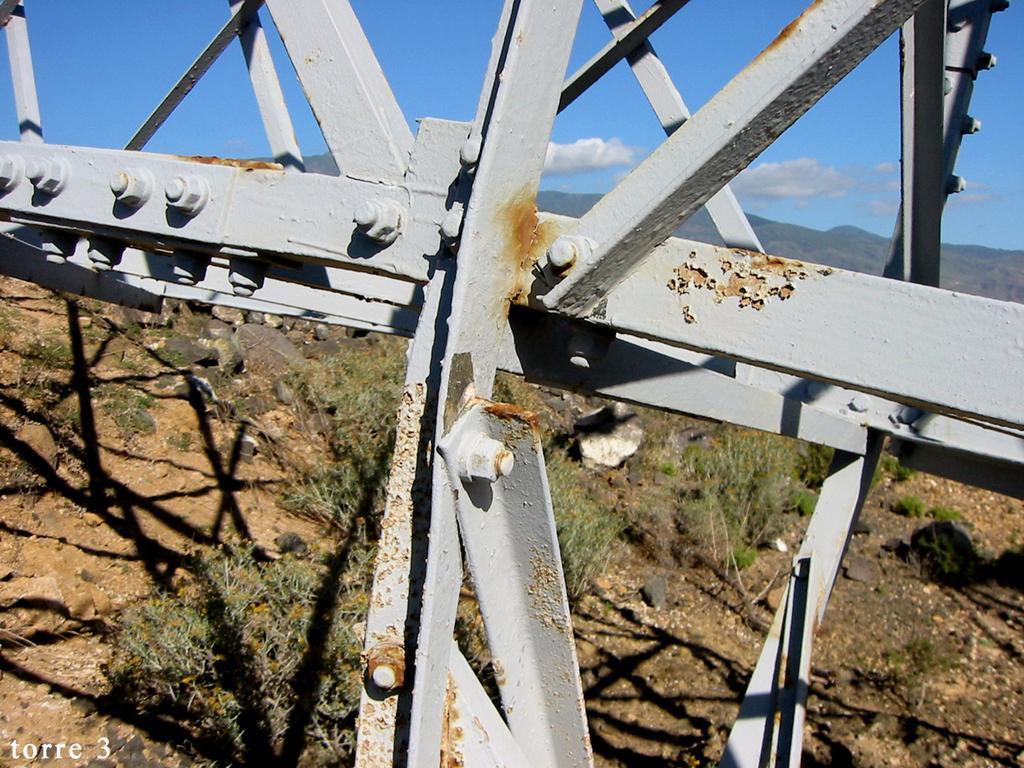Can you describe this image briefly? This picture is clicked outside. In the foreground we can see the metal objects and we can see the green grass, rocks, sky, clouds, hills and some other objects. In the bottom left corner we can see the watermark on the image. 